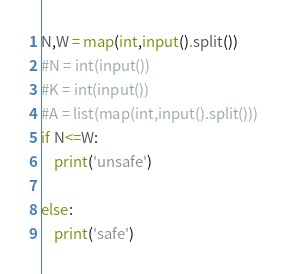<code> <loc_0><loc_0><loc_500><loc_500><_Python_>N,W = map(int,input().split())
#N = int(input())
#K = int(input())
#A = list(map(int,input().split()))
if N<=W:
    print('unsafe')

else:
    print('safe')
</code> 